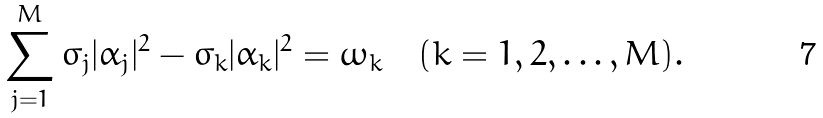<formula> <loc_0><loc_0><loc_500><loc_500>\sum _ { j = 1 } ^ { M } \sigma _ { j } | \alpha _ { j } | ^ { 2 } - \sigma _ { k } | \alpha _ { k } | ^ { 2 } = \omega _ { k } \quad ( k = 1 , 2 , \dots , M ) .</formula> 